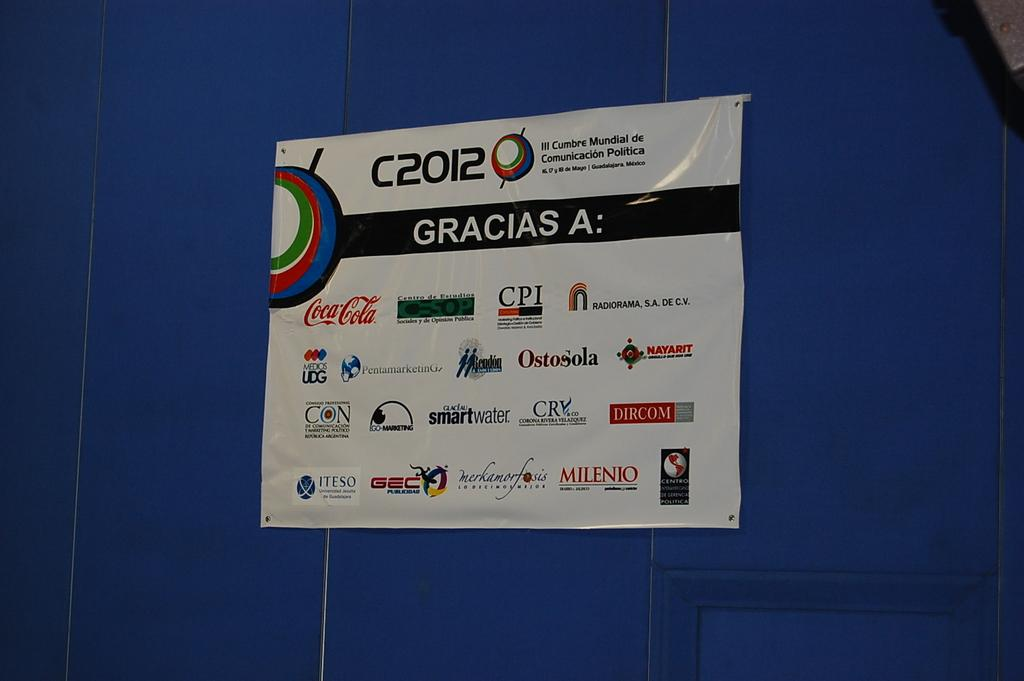<image>
Present a compact description of the photo's key features. A sign on a wall says Gracias A and has sponsors all over it like Coca Cola and CPI 